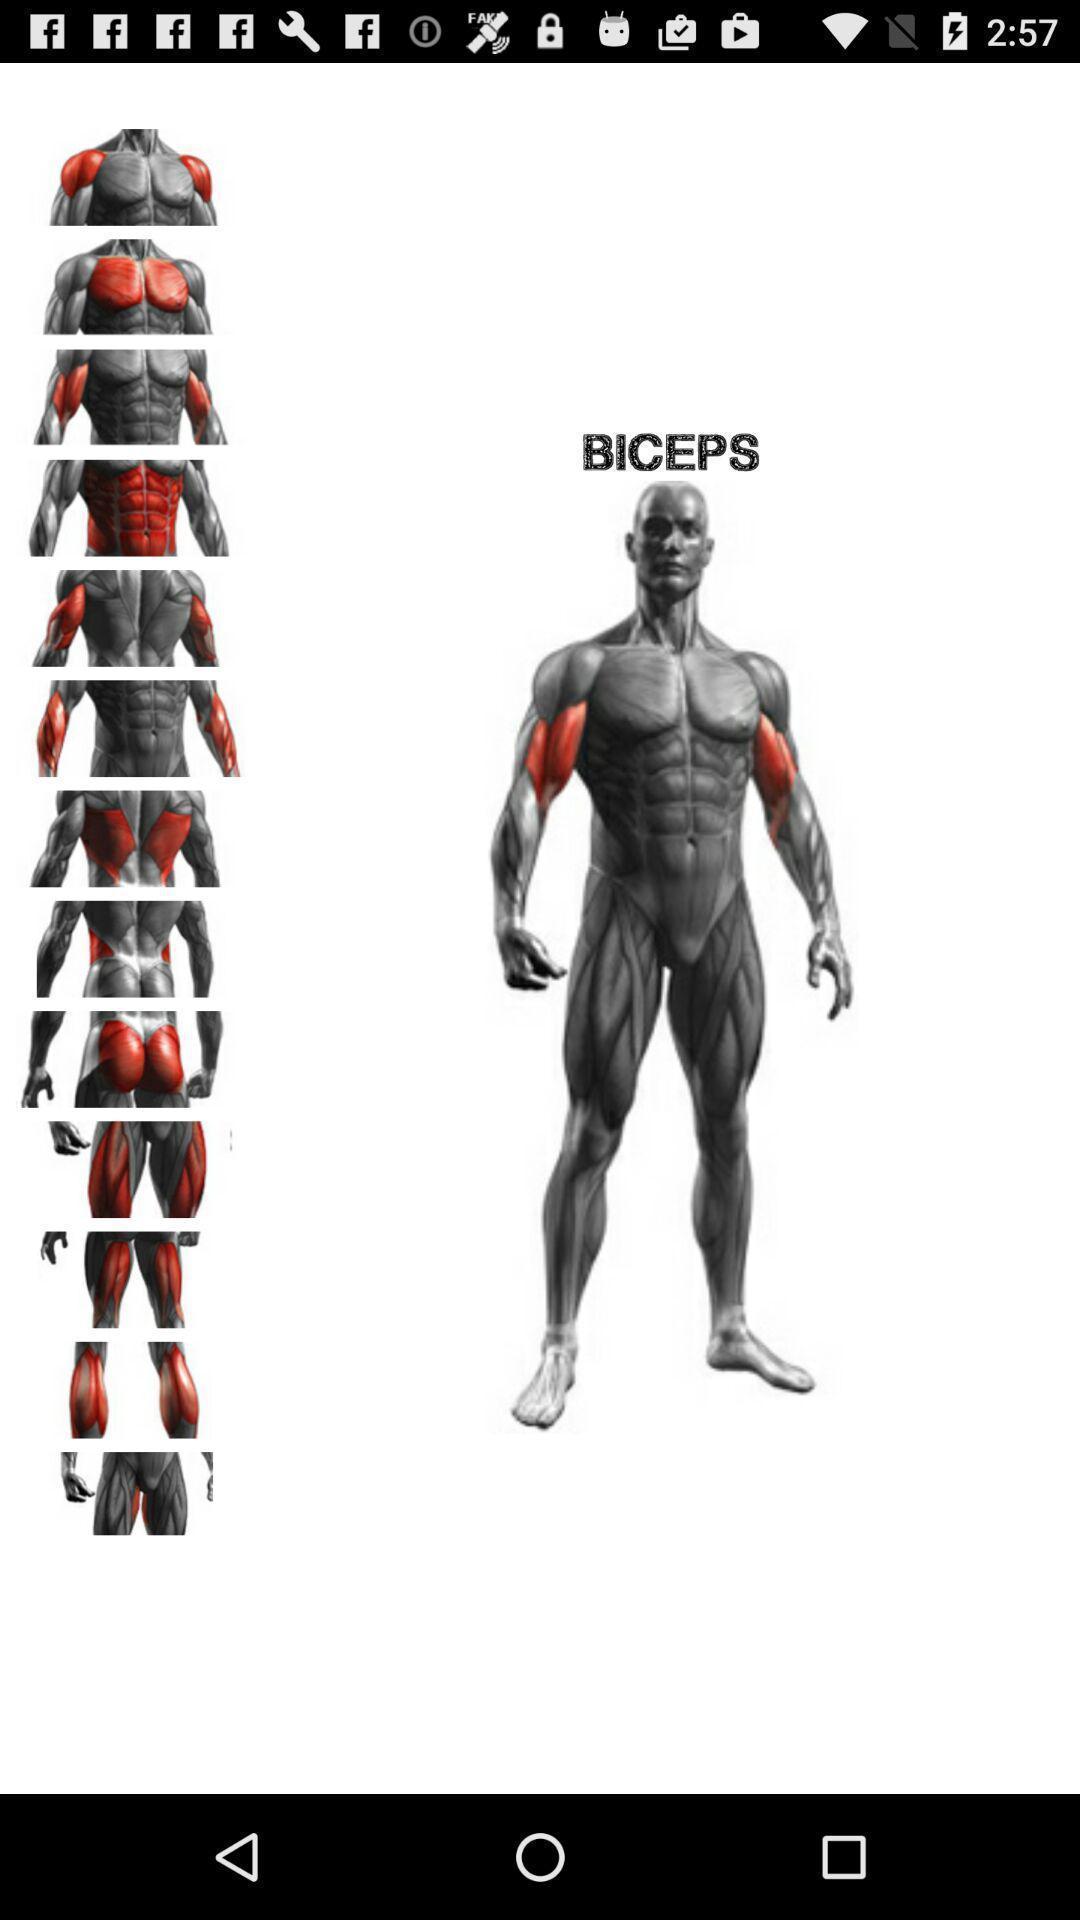Give me a narrative description of this picture. Screen shows an image in fitness app. 